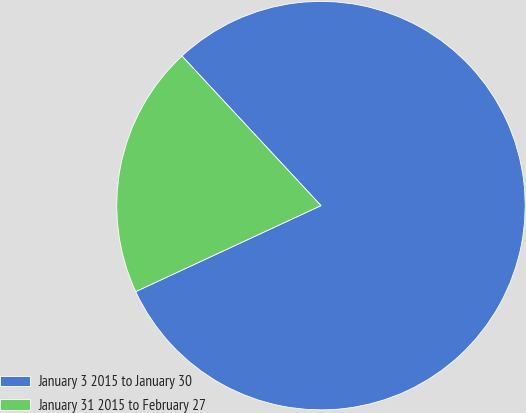<chart> <loc_0><loc_0><loc_500><loc_500><pie_chart><fcel>January 3 2015 to January 30<fcel>January 31 2015 to February 27<nl><fcel>80.0%<fcel>20.0%<nl></chart> 